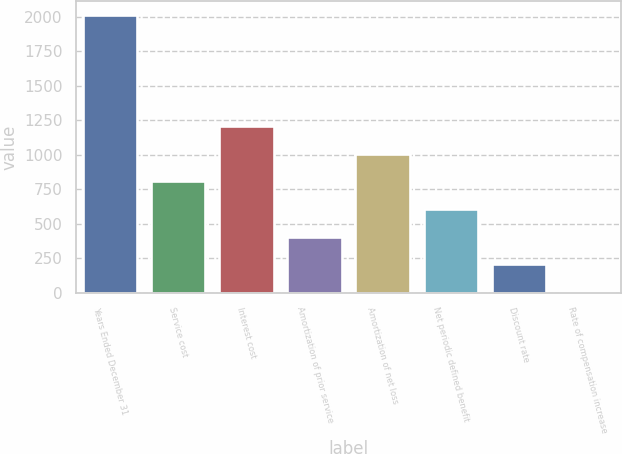Convert chart to OTSL. <chart><loc_0><loc_0><loc_500><loc_500><bar_chart><fcel>Years Ended December 31<fcel>Service cost<fcel>Interest cost<fcel>Amortization of prior service<fcel>Amortization of net loss<fcel>Net periodic defined benefit<fcel>Discount rate<fcel>Rate of compensation increase<nl><fcel>2014<fcel>808<fcel>1210<fcel>406<fcel>1009<fcel>607<fcel>205<fcel>4<nl></chart> 